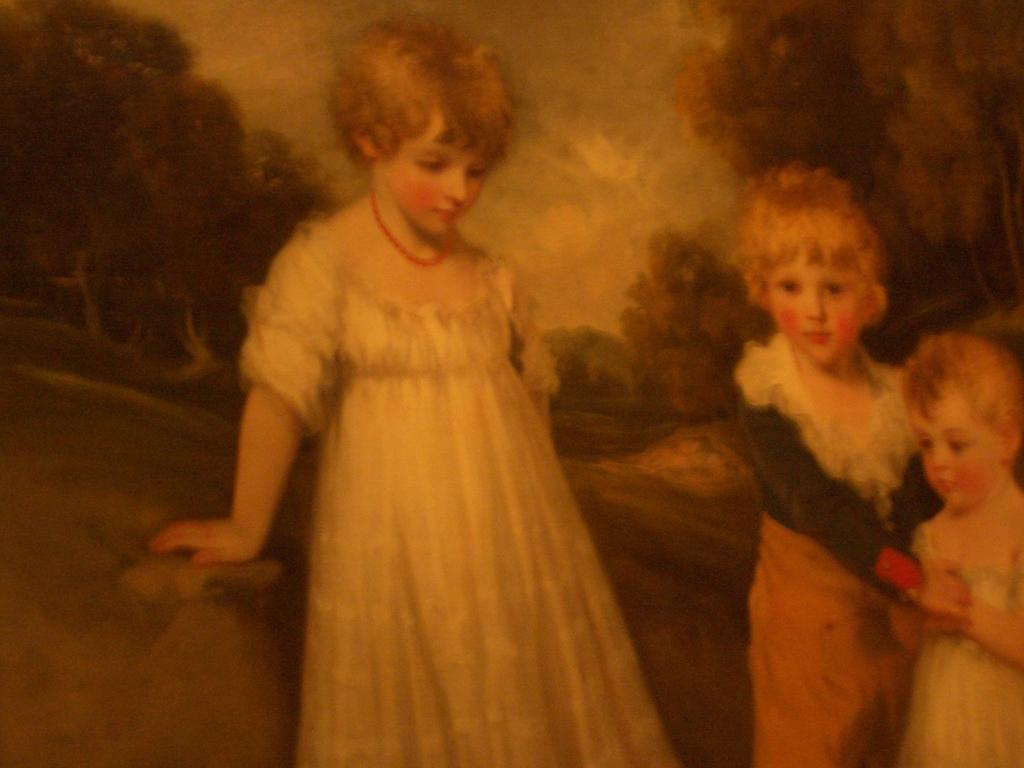What is the main subject of the image? The image contains a painting. What is depicted in the painting? The painting depicts three children. What are the children wearing in the painting? The children are wearing clothes in the painting. What are the children doing in the painting? The children are standing in the painting. What can be seen in the background of the painting? There are many trees and the sky visible in the background of the painting. What type of collar can be seen on the pickle in the image? There is no pickle present in the image, and therefore no collar can be seen on it. 